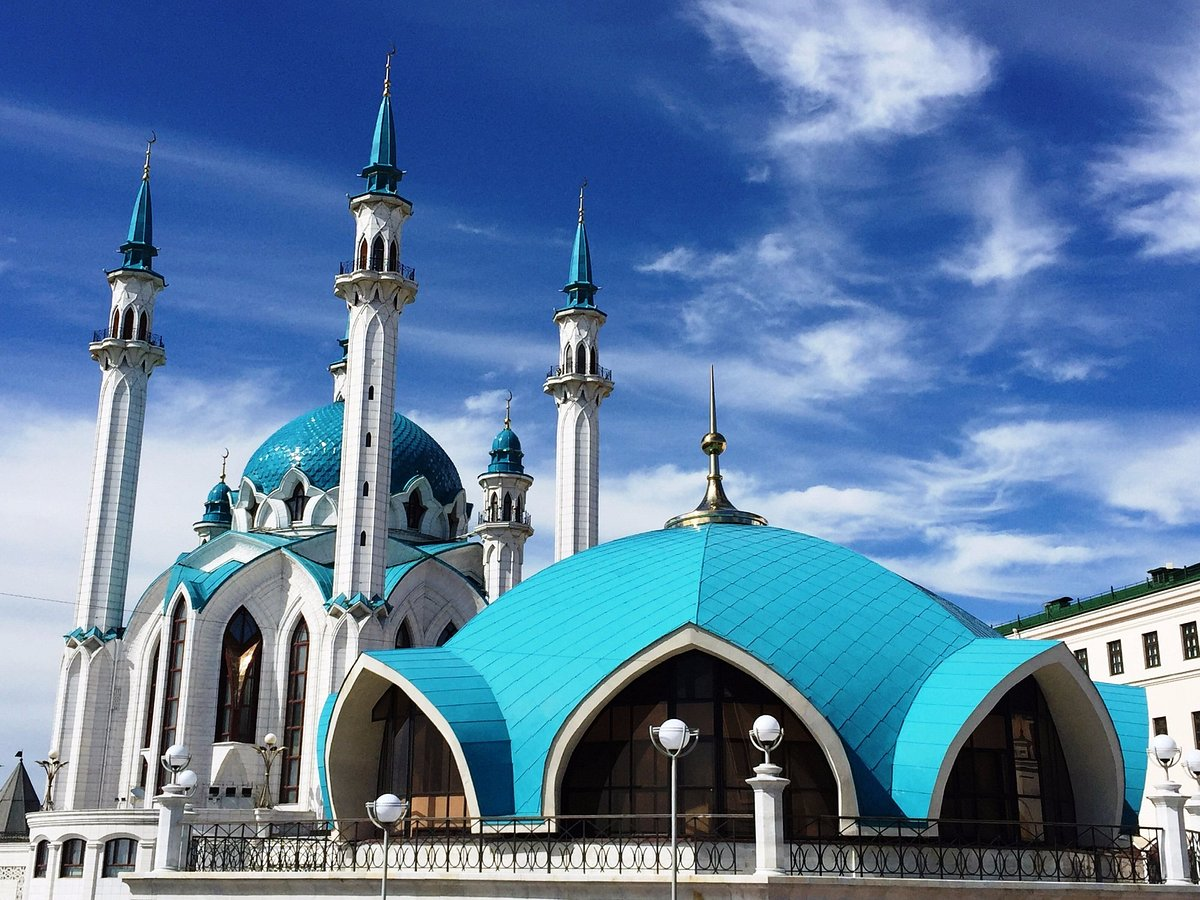How does the architecture of this mosque compare to other famous mosques around the world? Qolşärif Mosque exhibits a unique blend of Tatar and Russian architectural elements, making it distinctive when compared to other world-renowned mosques. Unlike the intricate ornamentation of Islamic architecture seen in mosques like the Blue Mosque in Istanbul, Qolşärif uses simpler, yet striking blue and white colors. The mosque's design features four minarets and a large dome, typical of traditional mosque architecture, but incorporates modern construction techniques and materials. Its location within a Kremlin, typically a Russian fortress, symbolizes an intersection of different cultural influences. 